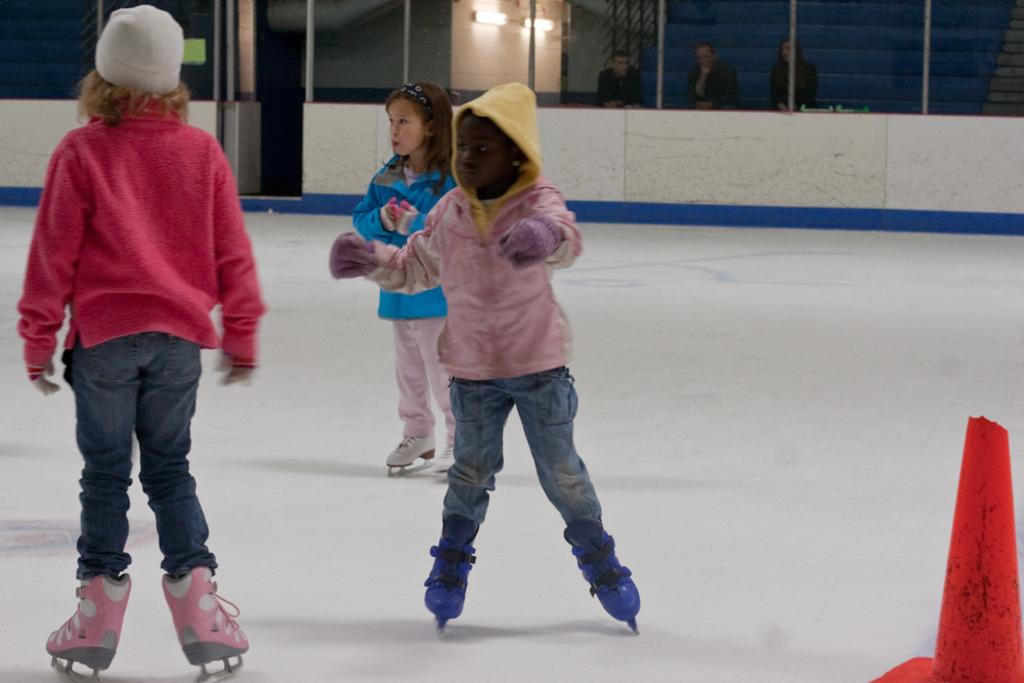What are the three persons in the image doing? The three persons in the image are figure skating. What object can be seen at the right bottom of the image? There is a cone at the right bottom of the image. Can you describe the background of the image? There are three persons and two lights visible in the background of the image. What type of request can be seen being made by the figure skaters in the image? There is no request visible in the image; it shows three persons figure skating and a cone at the right bottom. 